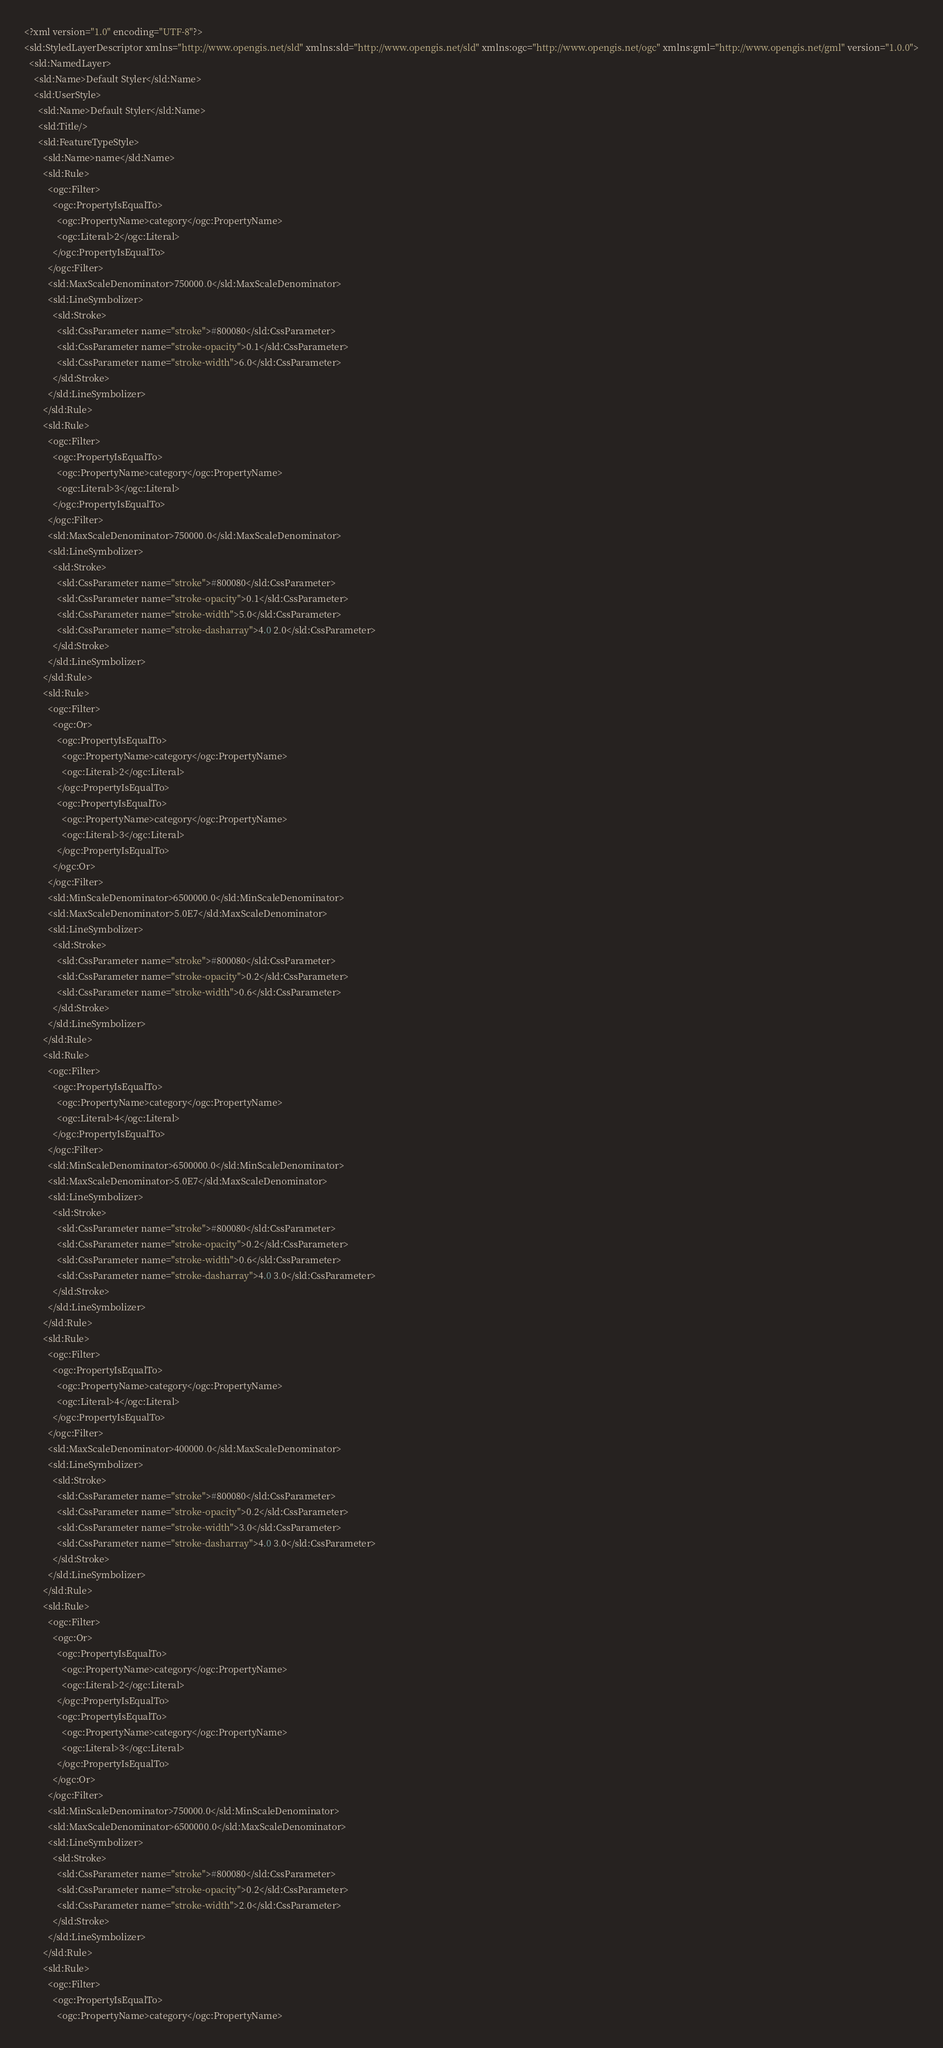Convert code to text. <code><loc_0><loc_0><loc_500><loc_500><_Scheme_><?xml version="1.0" encoding="UTF-8"?>
<sld:StyledLayerDescriptor xmlns="http://www.opengis.net/sld" xmlns:sld="http://www.opengis.net/sld" xmlns:ogc="http://www.opengis.net/ogc" xmlns:gml="http://www.opengis.net/gml" version="1.0.0">
  <sld:NamedLayer>
    <sld:Name>Default Styler</sld:Name>
    <sld:UserStyle>
      <sld:Name>Default Styler</sld:Name>
      <sld:Title/>
      <sld:FeatureTypeStyle>
        <sld:Name>name</sld:Name>
        <sld:Rule>
          <ogc:Filter>
            <ogc:PropertyIsEqualTo>
              <ogc:PropertyName>category</ogc:PropertyName>
              <ogc:Literal>2</ogc:Literal>
            </ogc:PropertyIsEqualTo>
          </ogc:Filter>
          <sld:MaxScaleDenominator>750000.0</sld:MaxScaleDenominator>
          <sld:LineSymbolizer>
            <sld:Stroke>
              <sld:CssParameter name="stroke">#800080</sld:CssParameter>
              <sld:CssParameter name="stroke-opacity">0.1</sld:CssParameter>
              <sld:CssParameter name="stroke-width">6.0</sld:CssParameter>
            </sld:Stroke>
          </sld:LineSymbolizer>
        </sld:Rule>
        <sld:Rule>
          <ogc:Filter>
            <ogc:PropertyIsEqualTo>
              <ogc:PropertyName>category</ogc:PropertyName>
              <ogc:Literal>3</ogc:Literal>
            </ogc:PropertyIsEqualTo>
          </ogc:Filter>
          <sld:MaxScaleDenominator>750000.0</sld:MaxScaleDenominator>
          <sld:LineSymbolizer>
            <sld:Stroke>
              <sld:CssParameter name="stroke">#800080</sld:CssParameter>
              <sld:CssParameter name="stroke-opacity">0.1</sld:CssParameter>
              <sld:CssParameter name="stroke-width">5.0</sld:CssParameter>
              <sld:CssParameter name="stroke-dasharray">4.0 2.0</sld:CssParameter>
            </sld:Stroke>
          </sld:LineSymbolizer>
        </sld:Rule>
        <sld:Rule>
          <ogc:Filter>
            <ogc:Or>
              <ogc:PropertyIsEqualTo>
                <ogc:PropertyName>category</ogc:PropertyName>
                <ogc:Literal>2</ogc:Literal>
              </ogc:PropertyIsEqualTo>
              <ogc:PropertyIsEqualTo>
                <ogc:PropertyName>category</ogc:PropertyName>
                <ogc:Literal>3</ogc:Literal>
              </ogc:PropertyIsEqualTo>
            </ogc:Or>
          </ogc:Filter>
          <sld:MinScaleDenominator>6500000.0</sld:MinScaleDenominator>
          <sld:MaxScaleDenominator>5.0E7</sld:MaxScaleDenominator>
          <sld:LineSymbolizer>
            <sld:Stroke>
              <sld:CssParameter name="stroke">#800080</sld:CssParameter>
              <sld:CssParameter name="stroke-opacity">0.2</sld:CssParameter>
              <sld:CssParameter name="stroke-width">0.6</sld:CssParameter>
            </sld:Stroke>
          </sld:LineSymbolizer>
        </sld:Rule>
        <sld:Rule>
          <ogc:Filter>
            <ogc:PropertyIsEqualTo>
              <ogc:PropertyName>category</ogc:PropertyName>
              <ogc:Literal>4</ogc:Literal>
            </ogc:PropertyIsEqualTo>
          </ogc:Filter>
          <sld:MinScaleDenominator>6500000.0</sld:MinScaleDenominator>
          <sld:MaxScaleDenominator>5.0E7</sld:MaxScaleDenominator>
          <sld:LineSymbolizer>
            <sld:Stroke>
              <sld:CssParameter name="stroke">#800080</sld:CssParameter>
              <sld:CssParameter name="stroke-opacity">0.2</sld:CssParameter>
              <sld:CssParameter name="stroke-width">0.6</sld:CssParameter>
              <sld:CssParameter name="stroke-dasharray">4.0 3.0</sld:CssParameter>
            </sld:Stroke>
          </sld:LineSymbolizer>
        </sld:Rule>
        <sld:Rule>
          <ogc:Filter>
            <ogc:PropertyIsEqualTo>
              <ogc:PropertyName>category</ogc:PropertyName>
              <ogc:Literal>4</ogc:Literal>
            </ogc:PropertyIsEqualTo>
          </ogc:Filter>
          <sld:MaxScaleDenominator>400000.0</sld:MaxScaleDenominator>
          <sld:LineSymbolizer>
            <sld:Stroke>
              <sld:CssParameter name="stroke">#800080</sld:CssParameter>
              <sld:CssParameter name="stroke-opacity">0.2</sld:CssParameter>
              <sld:CssParameter name="stroke-width">3.0</sld:CssParameter>
              <sld:CssParameter name="stroke-dasharray">4.0 3.0</sld:CssParameter>
            </sld:Stroke>
          </sld:LineSymbolizer>
        </sld:Rule>
        <sld:Rule>
          <ogc:Filter>
            <ogc:Or>
              <ogc:PropertyIsEqualTo>
                <ogc:PropertyName>category</ogc:PropertyName>
                <ogc:Literal>2</ogc:Literal>
              </ogc:PropertyIsEqualTo>
              <ogc:PropertyIsEqualTo>
                <ogc:PropertyName>category</ogc:PropertyName>
                <ogc:Literal>3</ogc:Literal>
              </ogc:PropertyIsEqualTo>
            </ogc:Or>
          </ogc:Filter>
          <sld:MinScaleDenominator>750000.0</sld:MinScaleDenominator>
          <sld:MaxScaleDenominator>6500000.0</sld:MaxScaleDenominator>
          <sld:LineSymbolizer>
            <sld:Stroke>
              <sld:CssParameter name="stroke">#800080</sld:CssParameter>
              <sld:CssParameter name="stroke-opacity">0.2</sld:CssParameter>
              <sld:CssParameter name="stroke-width">2.0</sld:CssParameter>
            </sld:Stroke>
          </sld:LineSymbolizer>
        </sld:Rule>
        <sld:Rule>
          <ogc:Filter>
            <ogc:PropertyIsEqualTo>
              <ogc:PropertyName>category</ogc:PropertyName></code> 